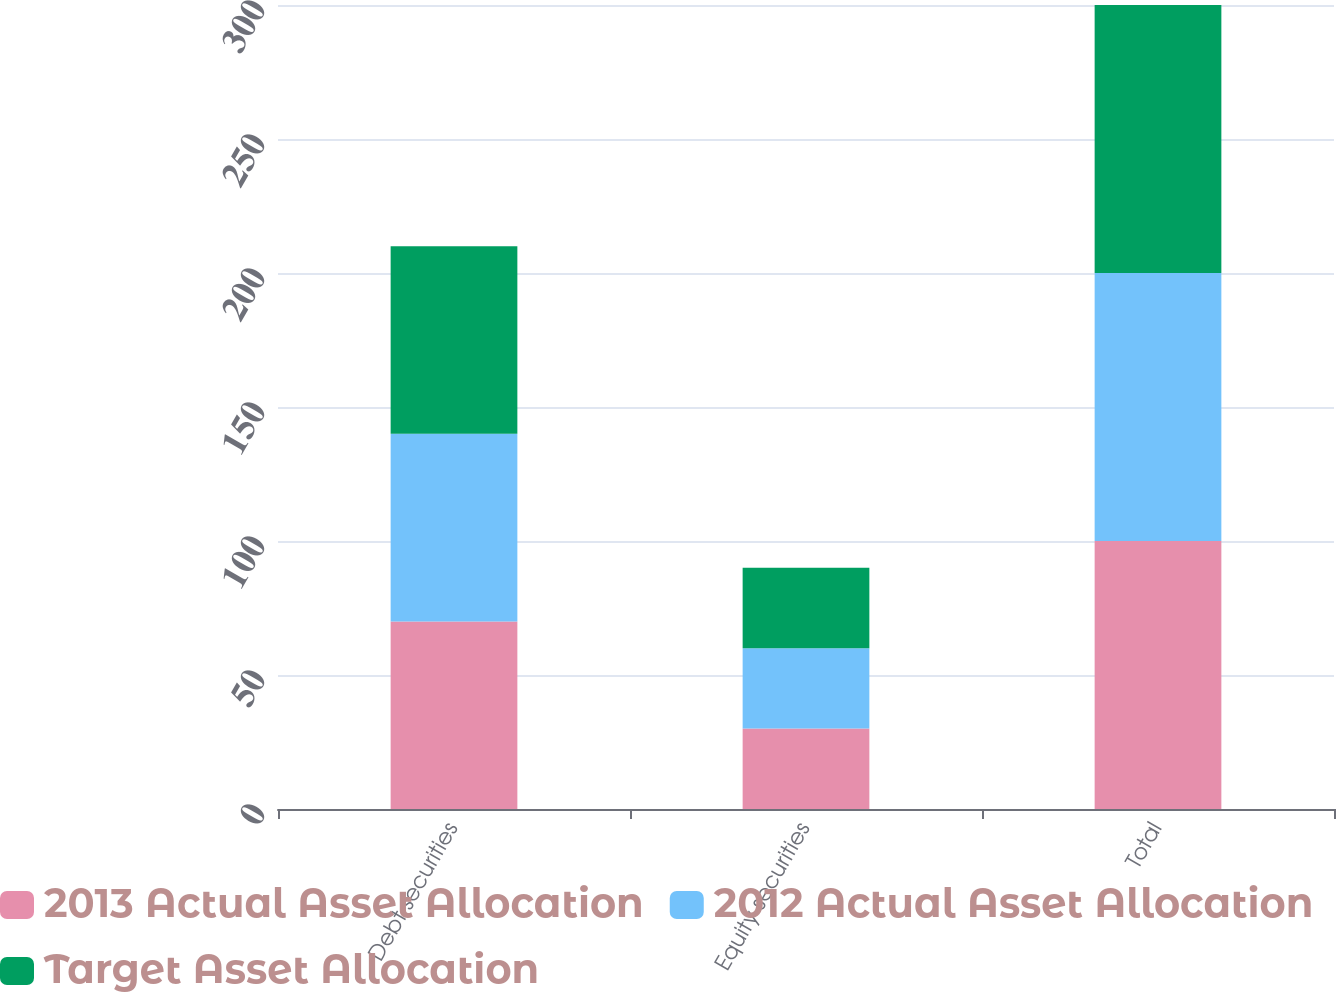Convert chart. <chart><loc_0><loc_0><loc_500><loc_500><stacked_bar_chart><ecel><fcel>Debt securities<fcel>Equity securities<fcel>Total<nl><fcel>2013 Actual Asset Allocation<fcel>70<fcel>30<fcel>100<nl><fcel>2012 Actual Asset Allocation<fcel>70<fcel>30<fcel>100<nl><fcel>Target Asset Allocation<fcel>70<fcel>30<fcel>100<nl></chart> 